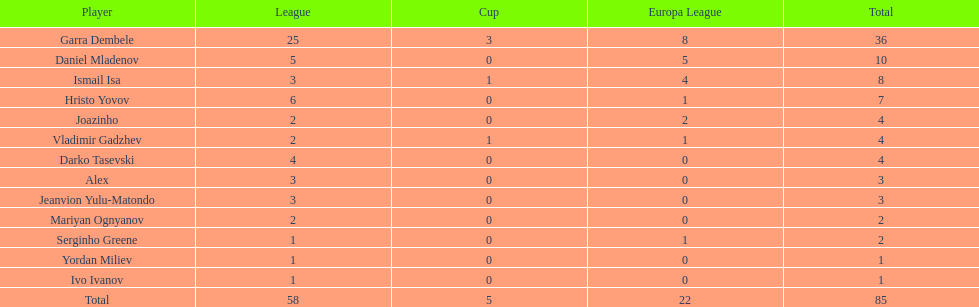Which participants hold at least 4 in the europa league? Garra Dembele, Daniel Mladenov, Ismail Isa. 